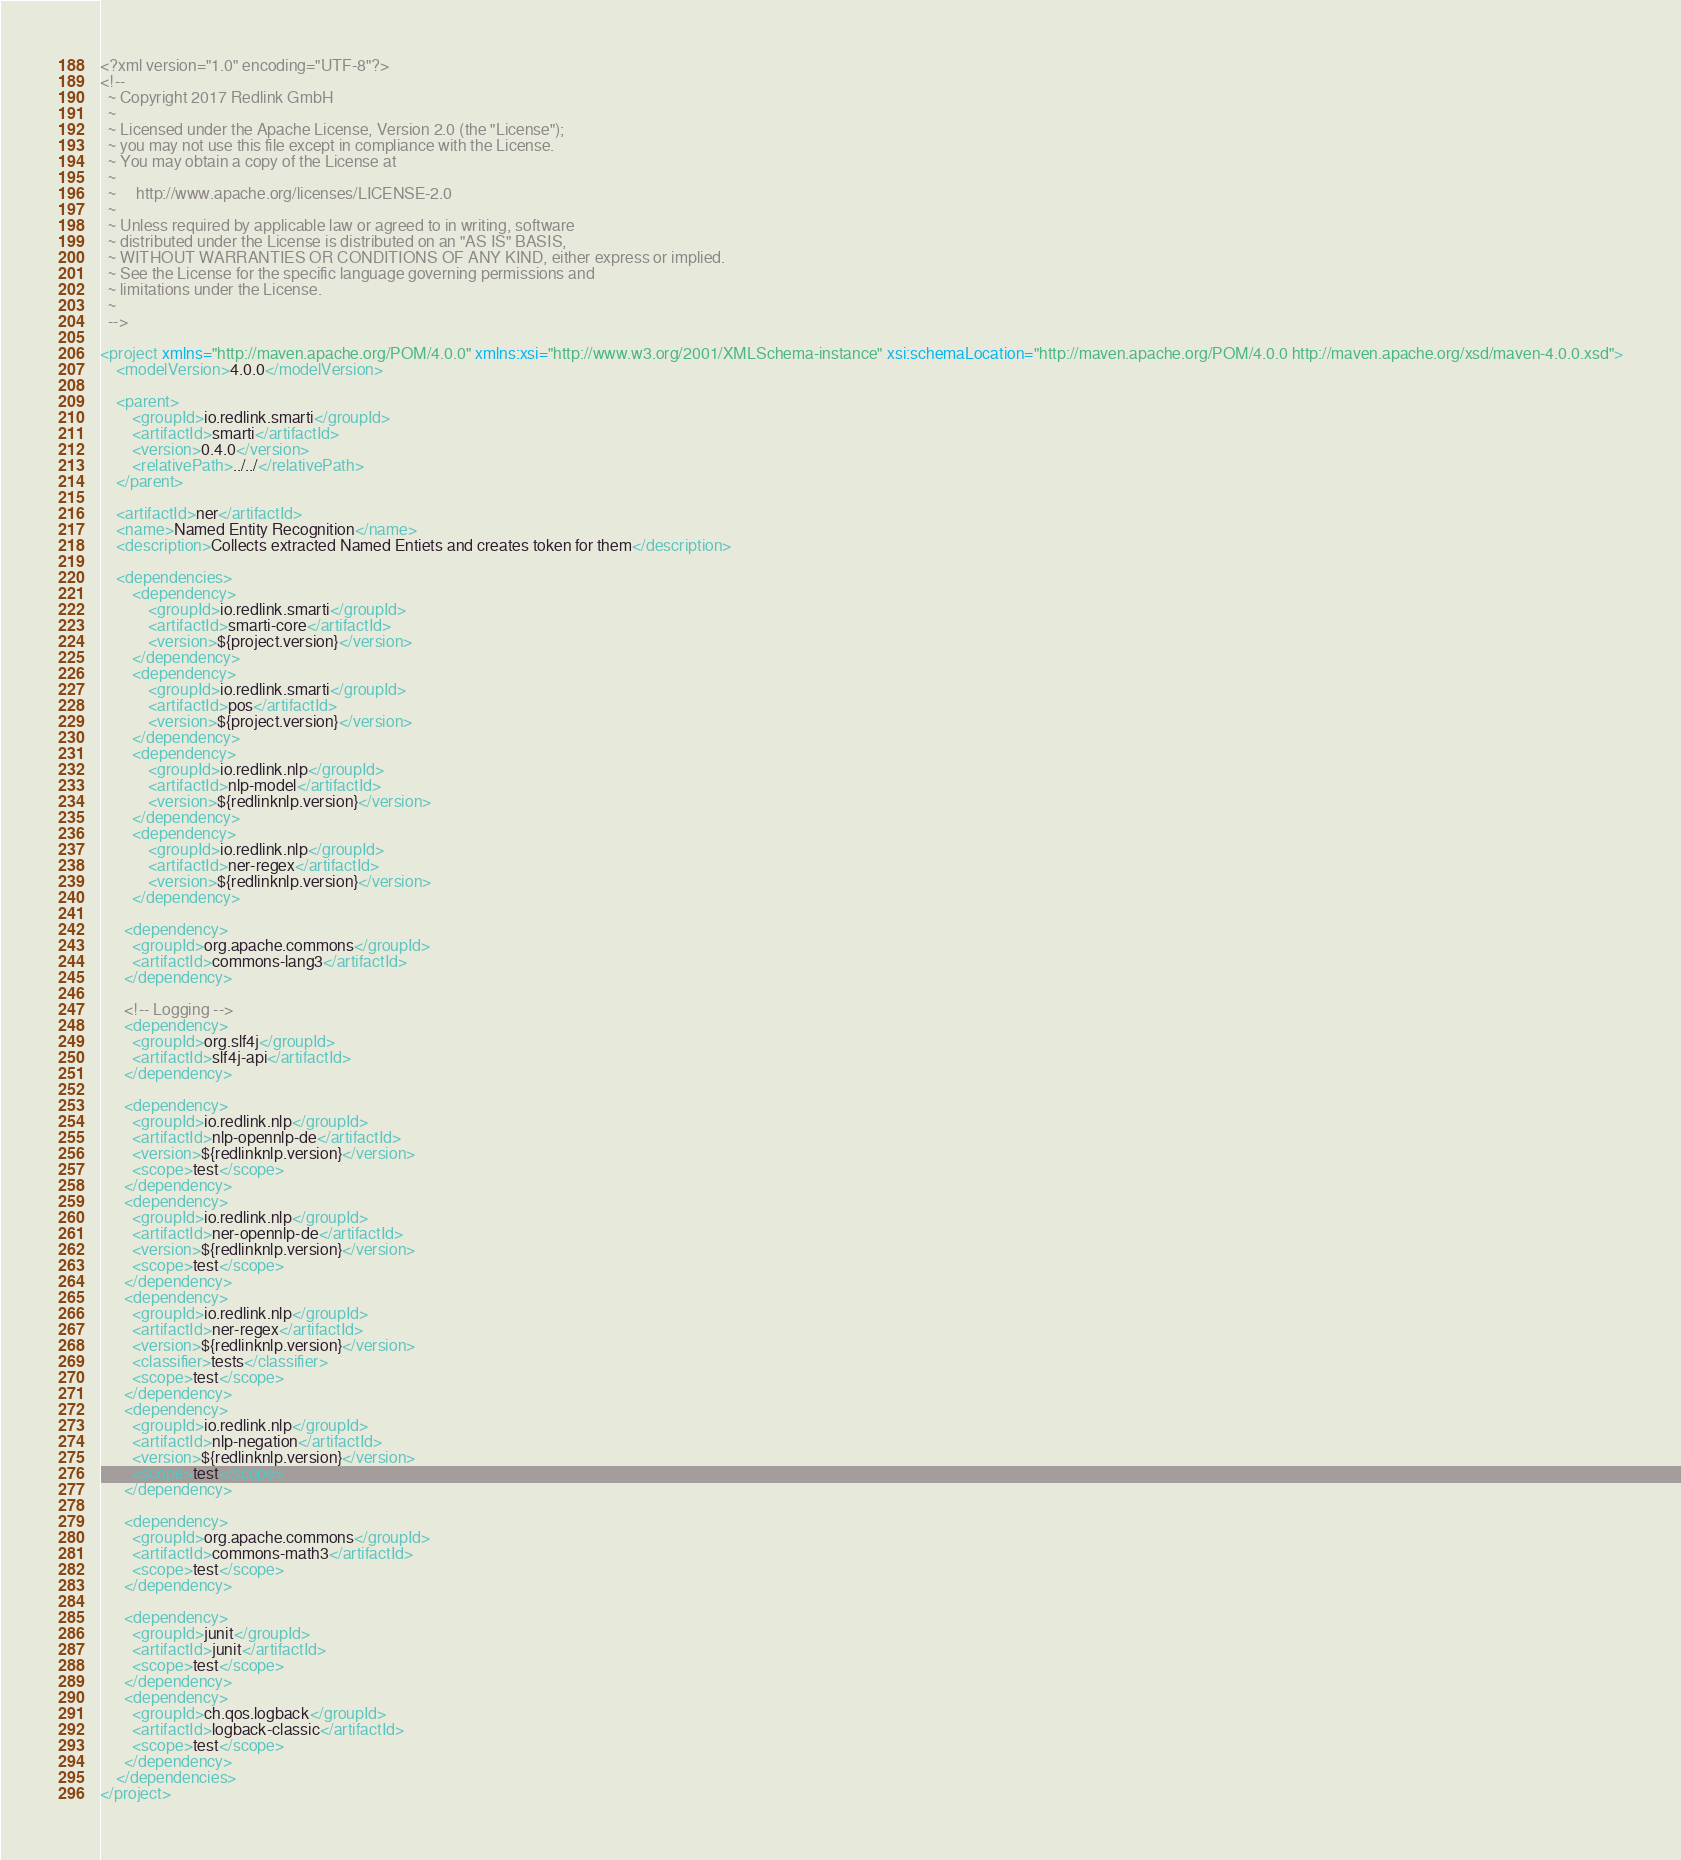Convert code to text. <code><loc_0><loc_0><loc_500><loc_500><_XML_><?xml version="1.0" encoding="UTF-8"?>
<!--
  ~ Copyright 2017 Redlink GmbH
  ~
  ~ Licensed under the Apache License, Version 2.0 (the "License");
  ~ you may not use this file except in compliance with the License.
  ~ You may obtain a copy of the License at
  ~
  ~     http://www.apache.org/licenses/LICENSE-2.0
  ~
  ~ Unless required by applicable law or agreed to in writing, software
  ~ distributed under the License is distributed on an "AS IS" BASIS,
  ~ WITHOUT WARRANTIES OR CONDITIONS OF ANY KIND, either express or implied.
  ~ See the License for the specific language governing permissions and
  ~ limitations under the License.
  ~
  -->

<project xmlns="http://maven.apache.org/POM/4.0.0" xmlns:xsi="http://www.w3.org/2001/XMLSchema-instance" xsi:schemaLocation="http://maven.apache.org/POM/4.0.0 http://maven.apache.org/xsd/maven-4.0.0.xsd">
    <modelVersion>4.0.0</modelVersion>

    <parent>
        <groupId>io.redlink.smarti</groupId>
        <artifactId>smarti</artifactId>
        <version>0.4.0</version>
        <relativePath>../../</relativePath>
    </parent>

    <artifactId>ner</artifactId>
    <name>Named Entity Recognition</name>
    <description>Collects extracted Named Entiets and creates token for them</description>
    
    <dependencies>
        <dependency>
            <groupId>io.redlink.smarti</groupId>
            <artifactId>smarti-core</artifactId>
            <version>${project.version}</version>
        </dependency>
        <dependency>
            <groupId>io.redlink.smarti</groupId>
            <artifactId>pos</artifactId>
            <version>${project.version}</version>
        </dependency>
        <dependency>
            <groupId>io.redlink.nlp</groupId>
            <artifactId>nlp-model</artifactId>
            <version>${redlinknlp.version}</version>
        </dependency>
        <dependency>
            <groupId>io.redlink.nlp</groupId>
            <artifactId>ner-regex</artifactId>
            <version>${redlinknlp.version}</version>
        </dependency>

      <dependency>
        <groupId>org.apache.commons</groupId>
        <artifactId>commons-lang3</artifactId>
      </dependency>
      
      <!-- Logging -->
      <dependency>
        <groupId>org.slf4j</groupId>
        <artifactId>slf4j-api</artifactId>
      </dependency>

      <dependency>
        <groupId>io.redlink.nlp</groupId>
        <artifactId>nlp-opennlp-de</artifactId>
        <version>${redlinknlp.version}</version>
        <scope>test</scope>
      </dependency>
      <dependency>
        <groupId>io.redlink.nlp</groupId>
        <artifactId>ner-opennlp-de</artifactId>
        <version>${redlinknlp.version}</version>
        <scope>test</scope>
      </dependency>
      <dependency>
        <groupId>io.redlink.nlp</groupId>
        <artifactId>ner-regex</artifactId>
        <version>${redlinknlp.version}</version>
        <classifier>tests</classifier>
        <scope>test</scope>
      </dependency>
      <dependency>
        <groupId>io.redlink.nlp</groupId>
        <artifactId>nlp-negation</artifactId>
        <version>${redlinknlp.version}</version>
        <scope>test</scope>
      </dependency>
      
      <dependency>
        <groupId>org.apache.commons</groupId>
        <artifactId>commons-math3</artifactId>
        <scope>test</scope>
      </dependency>

      <dependency>
        <groupId>junit</groupId>
        <artifactId>junit</artifactId>
        <scope>test</scope>
      </dependency>
      <dependency>
        <groupId>ch.qos.logback</groupId>
        <artifactId>logback-classic</artifactId>
        <scope>test</scope>
      </dependency>
    </dependencies>    
</project>
</code> 